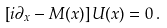<formula> <loc_0><loc_0><loc_500><loc_500>\left [ i \partial _ { x } - M ( x ) \right ] U ( x ) = 0 \, .</formula> 